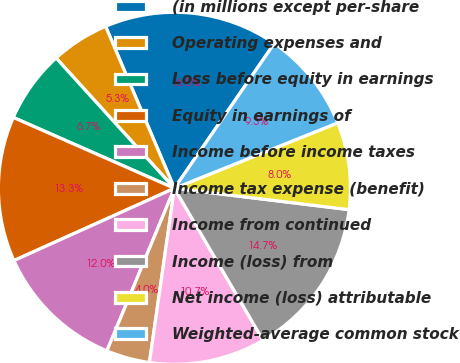<chart> <loc_0><loc_0><loc_500><loc_500><pie_chart><fcel>(in millions except per-share<fcel>Operating expenses and<fcel>Loss before equity in earnings<fcel>Equity in earnings of<fcel>Income before income taxes<fcel>Income tax expense (benefit)<fcel>Income from continued<fcel>Income (loss) from<fcel>Net income (loss) attributable<fcel>Weighted-average common stock<nl><fcel>16.0%<fcel>5.34%<fcel>6.67%<fcel>13.33%<fcel>12.0%<fcel>4.0%<fcel>10.67%<fcel>14.66%<fcel>8.0%<fcel>9.33%<nl></chart> 